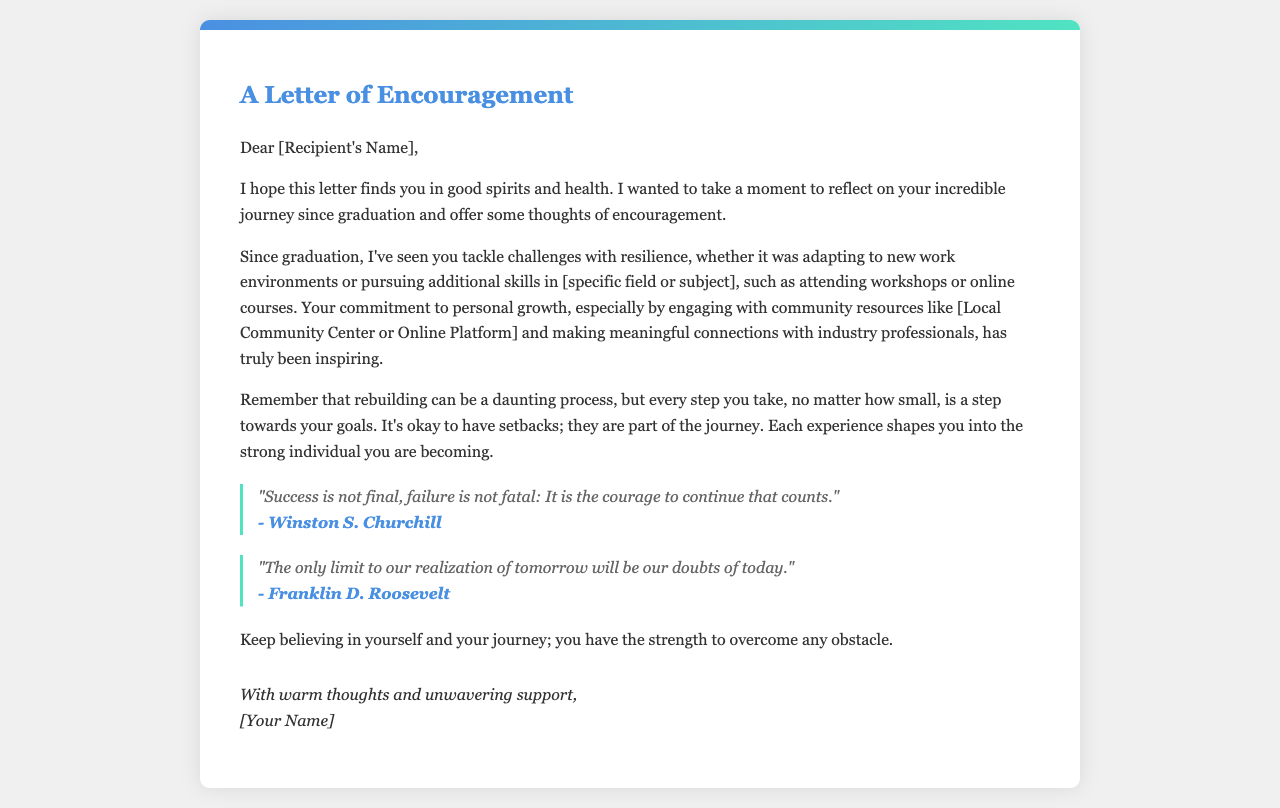What is the title of the letter? The title of the letter is presented in a prominent header at the top of the document.
Answer: A Letter of Encouragement Who is the letter addressed to? The recipient's name is indicated directly after the greeting in the letter.
Answer: [Recipient's Name] What is one skill the recipient has pursued since graduation? The letter mentions a specific field or subject where additional skills were pursued, indicating ongoing personal growth.
Answer: [specific field or subject] Which community resources does the letter mention? The letter highlights engagement with certain community resources to illustrate the recipient's commitment to personal growth.
Answer: [Local Community Center or Online Platform] Who is quoted in the first motivational quote? The author of the first quote, which discusses success and failure, is referenced in the document.
Answer: Winston S. Churchill What is one theme emphasized in the letter regarding setbacks? The letter discusses the nature of setbacks in the context of rebuilding and personal growth, signifying their importance in the journey.
Answer: They are part of the journey What does the author encourage the recipient to keep believing in? This encouragement reflects a core theme in the letter aimed at boosting the recipient's confidence in facing challenges.
Answer: Themselves and their journey How many motivational quotes are included in the letter? The letter contains two quotes to provide additional encouragement and motivation to the reader.
Answer: Two What is the closing sentiment of the letter? The conclusion of the letter encapsulates the author's supportive and warm tone towards the recipient.
Answer: With warm thoughts and unwavering support 